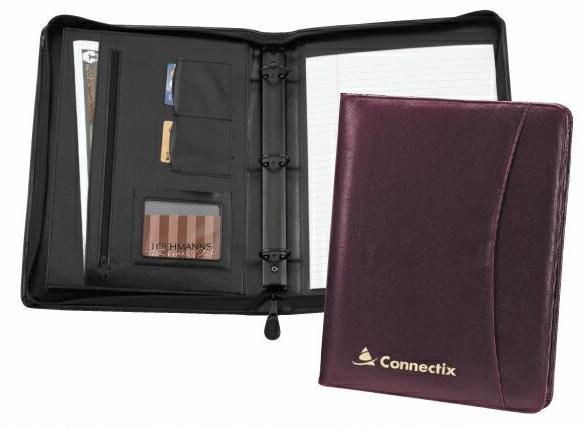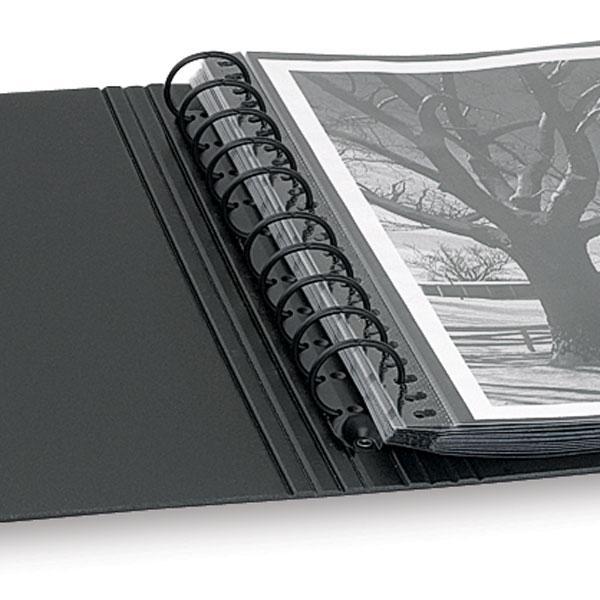The first image is the image on the left, the second image is the image on the right. Examine the images to the left and right. Is the description "One photo features a single closed binder with a brand label on the front." accurate? Answer yes or no. No. The first image is the image on the left, the second image is the image on the right. Assess this claim about the two images: "An image shows one closed black binder with a colored label on the front.". Correct or not? Answer yes or no. No. 